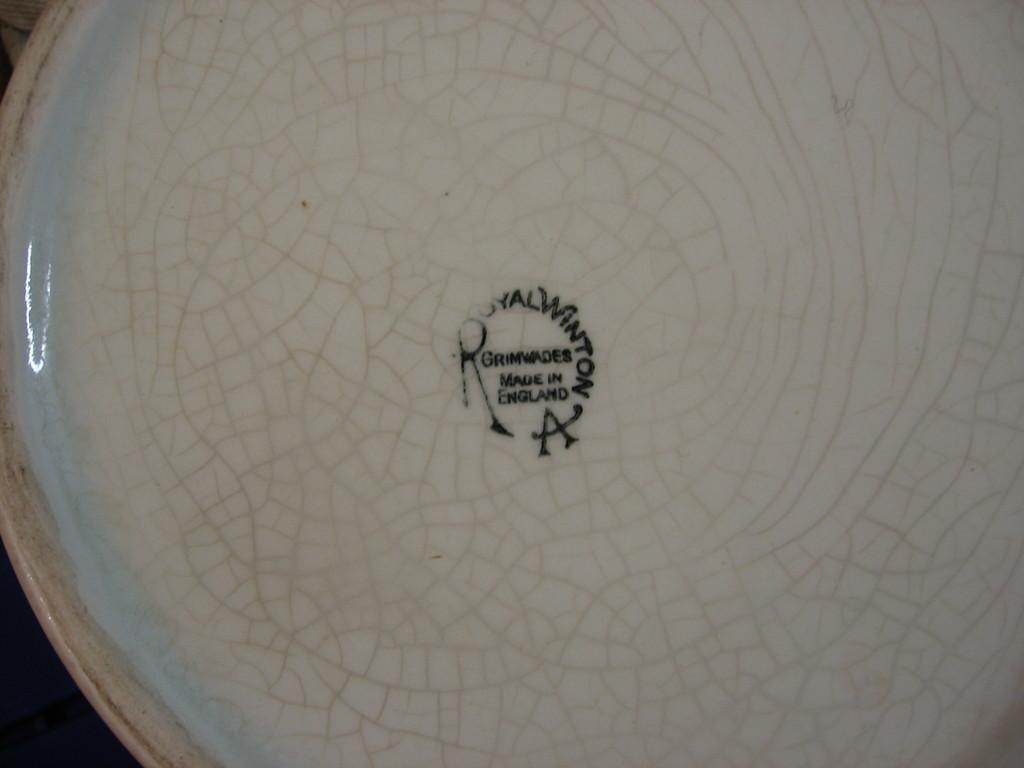Can you describe this image briefly? In this picture, we see an object in white color. This object looks like a plate. In the middle of the picture, we see some text written in black color. 